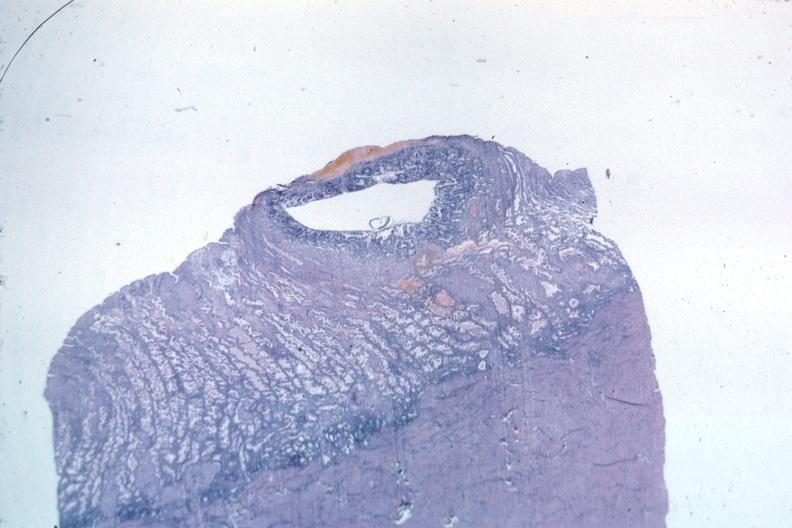where is this from?
Answer the question using a single word or phrase. Female reproductive system 